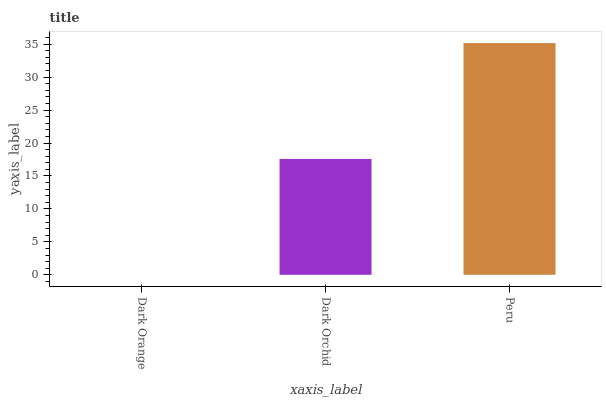Is Dark Orange the minimum?
Answer yes or no. Yes. Is Peru the maximum?
Answer yes or no. Yes. Is Dark Orchid the minimum?
Answer yes or no. No. Is Dark Orchid the maximum?
Answer yes or no. No. Is Dark Orchid greater than Dark Orange?
Answer yes or no. Yes. Is Dark Orange less than Dark Orchid?
Answer yes or no. Yes. Is Dark Orange greater than Dark Orchid?
Answer yes or no. No. Is Dark Orchid less than Dark Orange?
Answer yes or no. No. Is Dark Orchid the high median?
Answer yes or no. Yes. Is Dark Orchid the low median?
Answer yes or no. Yes. Is Peru the high median?
Answer yes or no. No. Is Dark Orange the low median?
Answer yes or no. No. 